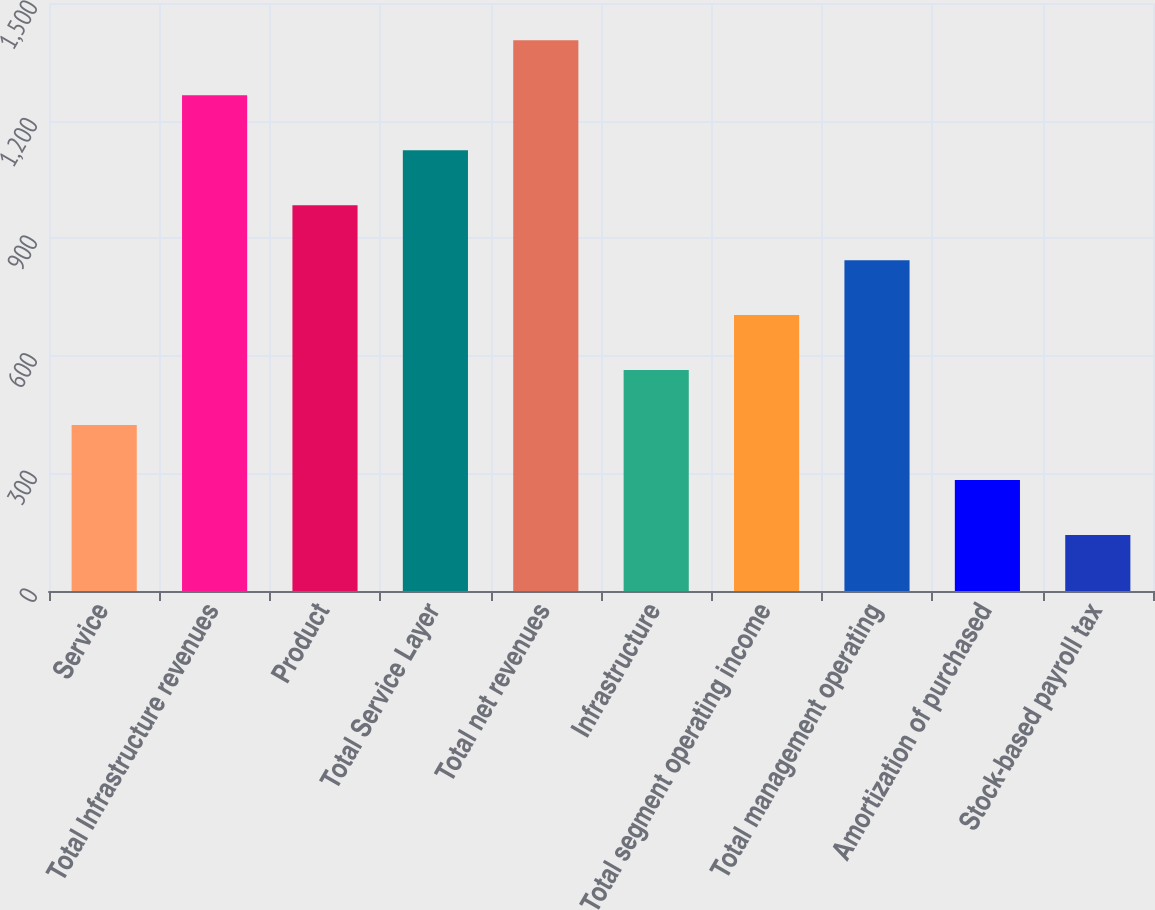<chart> <loc_0><loc_0><loc_500><loc_500><bar_chart><fcel>Service<fcel>Total Infrastructure revenues<fcel>Product<fcel>Total Service Layer<fcel>Total net revenues<fcel>Infrastructure<fcel>Total segment operating income<fcel>Total management operating<fcel>Amortization of purchased<fcel>Stock-based payroll tax<nl><fcel>423.43<fcel>1264.69<fcel>984.27<fcel>1124.48<fcel>1404.9<fcel>563.64<fcel>703.85<fcel>844.06<fcel>283.22<fcel>143.01<nl></chart> 